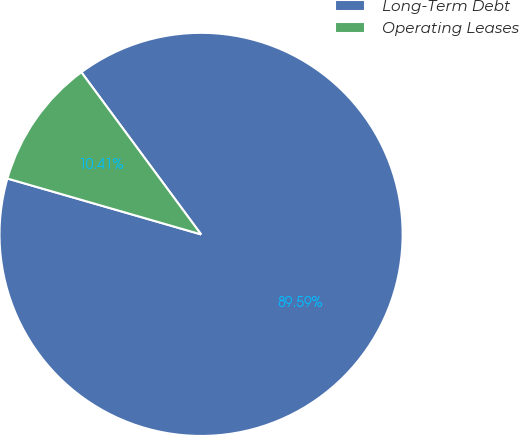<chart> <loc_0><loc_0><loc_500><loc_500><pie_chart><fcel>Long-Term Debt<fcel>Operating Leases<nl><fcel>89.59%<fcel>10.41%<nl></chart> 